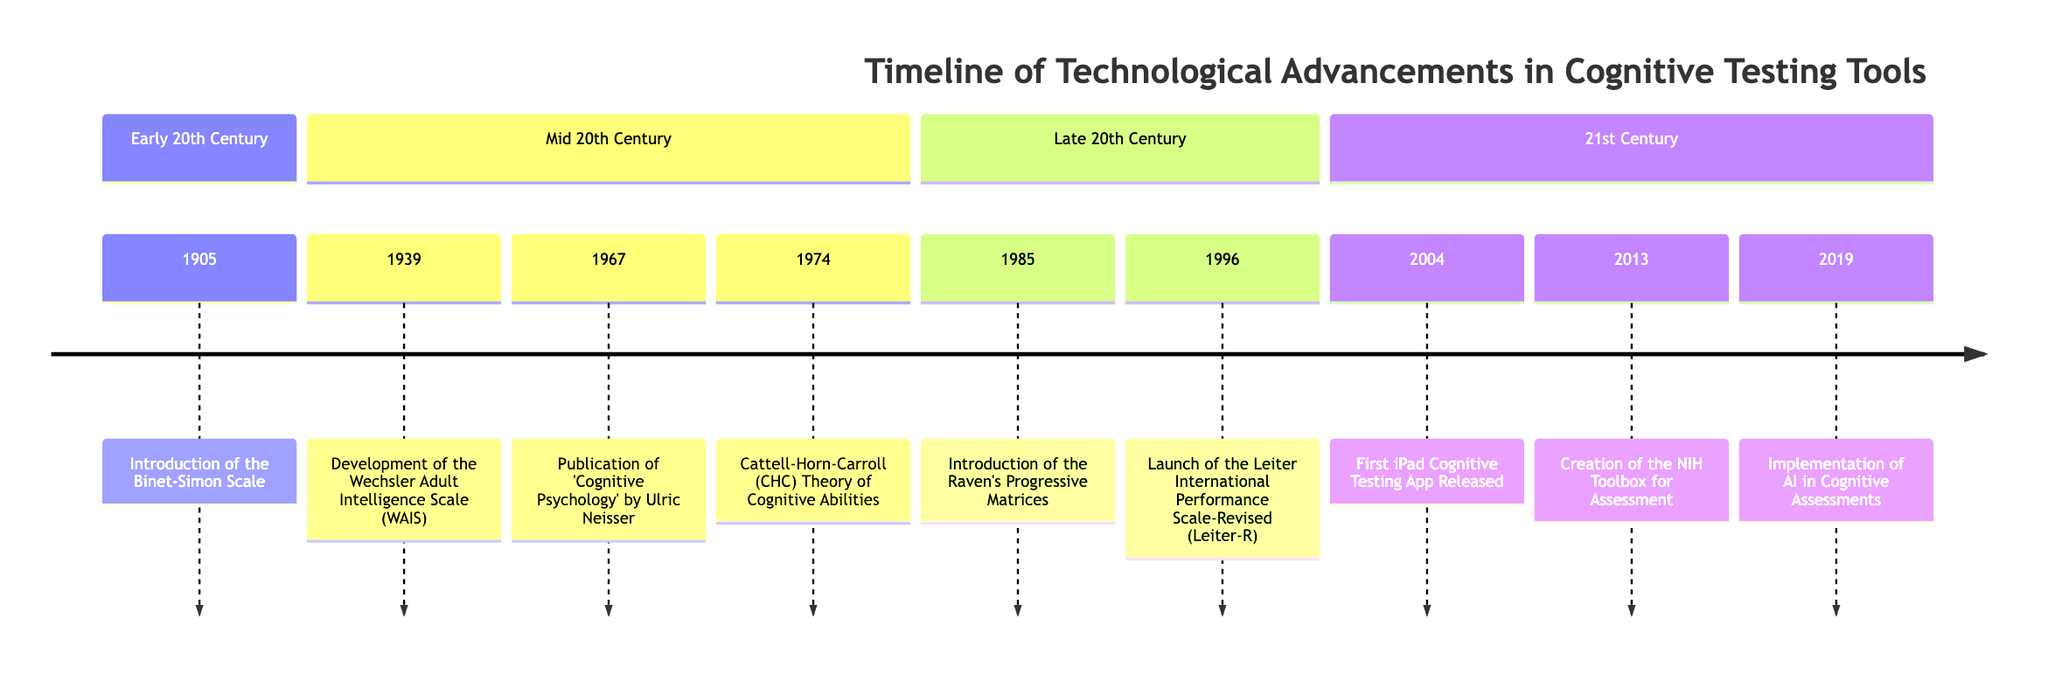What event occurred in 1905? The diagram indicates that in 1905, the event is the "Introduction of the Binet-Simon Scale."
Answer: Introduction of the Binet-Simon Scale How many years separate the introduction of the Binet-Simon Scale and the publication of 'Cognitive Psychology'? The Binet-Simon Scale was introduced in 1905, and 'Cognitive Psychology' was published in 1967. The difference is 1967 - 1905 = 62 years.
Answer: 62 What testing tool was released in 2004? According to the diagram, the event in 2004 is the "First iPad Cognitive Testing App Released."
Answer: First iPad Cognitive Testing App Released Which cognitive assessment tool was developed in 1985? The timeline shows that the "Introduction of the Raven's Progressive Matrices" occurred in 1985, making it the relevant tool from that year.
Answer: Introduction of the Raven's Progressive Matrices Which theory influenced modern cognitive testing tools, and in what year was it introduced? The Cattell-Horn-Carroll (CHC) Theory of Cognitive Abilities was introduced in 1974 and is stated in the diagram as influencing modern cognitive testing tools.
Answer: Cattell-Horn-Carroll (CHC) Theory of Cognitive Abilities, 1974 What significant advancement occurred in cognitive assessments in 2019? The diagram reveals that in 2019, there was the "Implementation of AI in Cognitive Assessments," which enhances precision and adaptability in testing tools.
Answer: Implementation of AI in Cognitive Assessments Compare the events of 1996 and 2013 regarding the development of cognitive tools. In 1996, the "Launch of the Leiter International Performance Scale-Revised (Leiter-R)" occurred, while in 2013, the "Creation of the NIH Toolbox for the Assessment of Neurological and Behavioral Function" happened. These two events show progressive advancements in cognitive testing tools over the years.
Answer: Leiter-R, NIH Toolbox What decade saw the development of the Wechsler Adult Intelligence Scale (WAIS)? Looking at the diagram, the WAIS was developed in 1939, which is in the 1930s decade.
Answer: 1930s Which concept does the event from 1974 relate to? The event from 1974, which is the "Cattell-Horn-Carroll (CHC) Theory of Cognitive Abilities," relates to an understanding of cognitive abilities and their testing.
Answer: Cattell-Horn-Carroll (CHC) Theory of Cognitive Abilities 